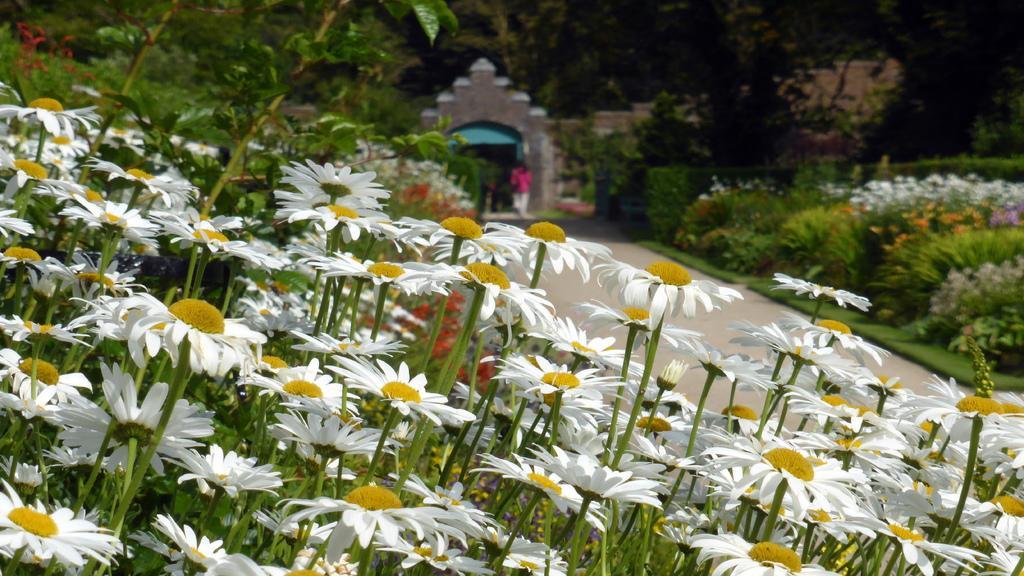Please provide a concise description of this image. In this image we can see flowers, plants, trees, also we can see a person, and the arch. 